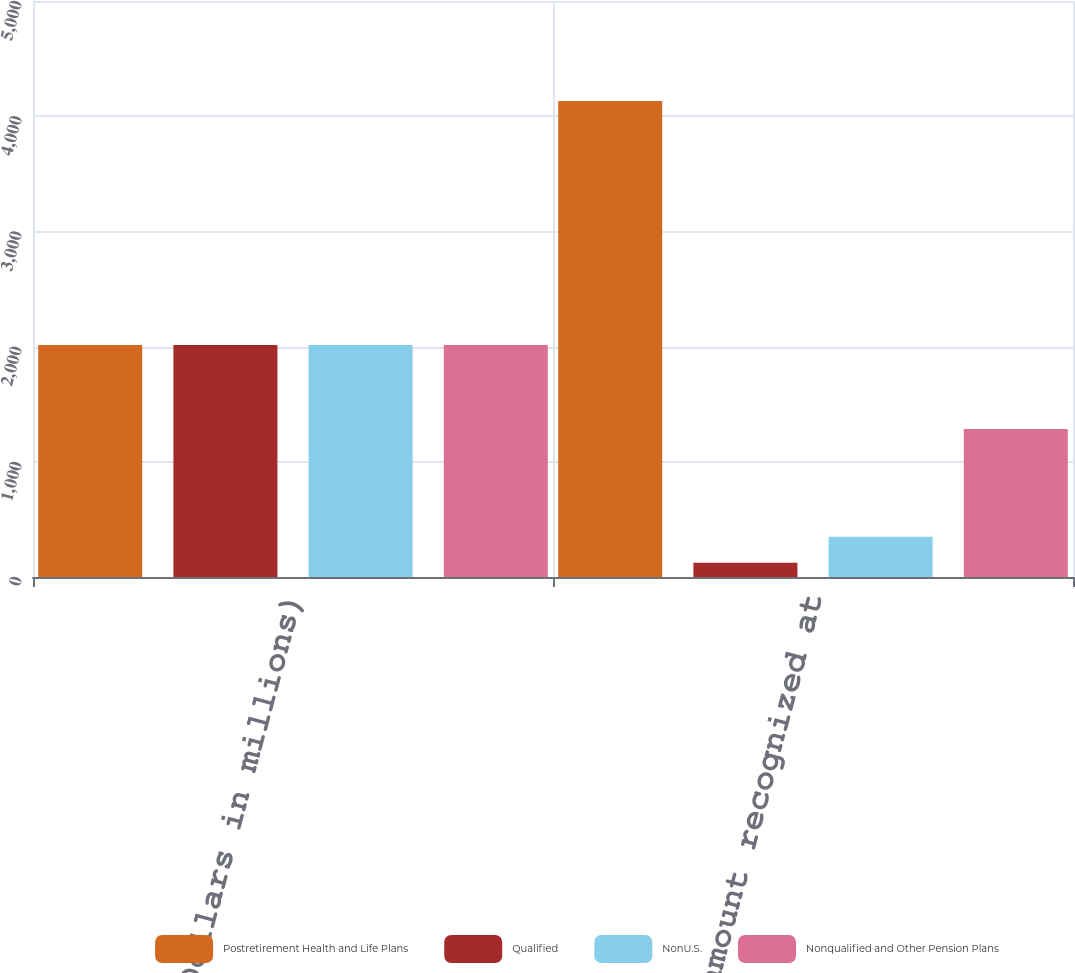Convert chart to OTSL. <chart><loc_0><loc_0><loc_500><loc_500><stacked_bar_chart><ecel><fcel>(Dollars in millions)<fcel>Net amount recognized at<nl><fcel>Postretirement Health and Life Plans<fcel>2013<fcel>4131<nl><fcel>Qualified<fcel>2013<fcel>123<nl><fcel>NonU.S.<fcel>2013<fcel>350<nl><fcel>Nonqualified and Other Pension Plans<fcel>2013<fcel>1284<nl></chart> 